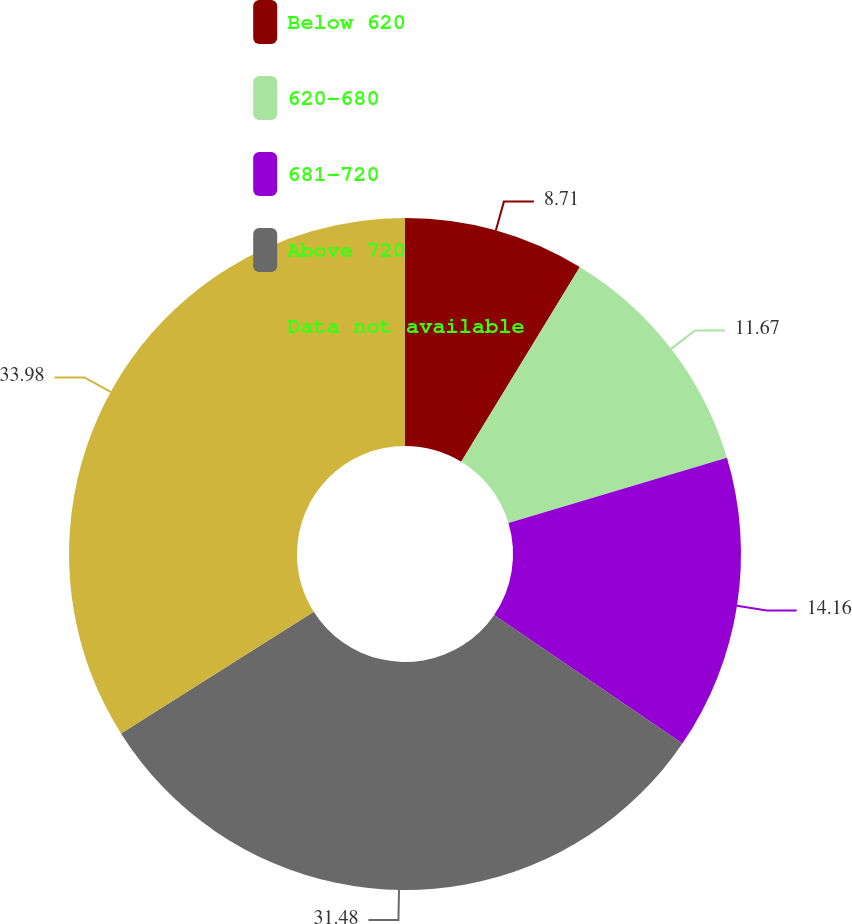<chart> <loc_0><loc_0><loc_500><loc_500><pie_chart><fcel>Below 620<fcel>620-680<fcel>681-720<fcel>Above 720<fcel>Data not available<nl><fcel>8.71%<fcel>11.67%<fcel>14.16%<fcel>31.48%<fcel>33.97%<nl></chart> 